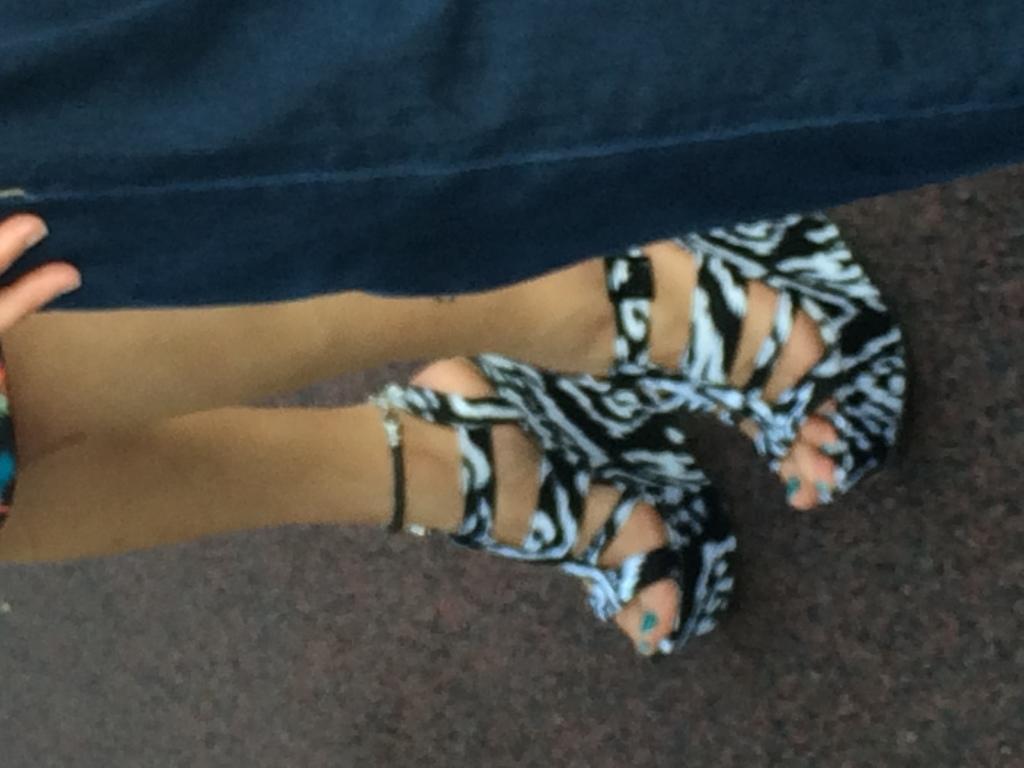How would you summarize this image in a sentence or two? In this image we can see that there are legs of a girl who is wearing the heels. Beside her we can see that there is a pant. 